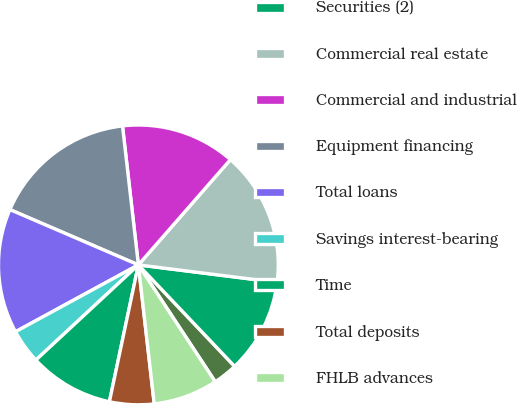<chart> <loc_0><loc_0><loc_500><loc_500><pie_chart><fcel>Short-term investments (1)<fcel>Securities (2)<fcel>Commercial real estate<fcel>Commercial and industrial<fcel>Equipment financing<fcel>Total loans<fcel>Savings interest-bearing<fcel>Time<fcel>Total deposits<fcel>FHLB advances<nl><fcel>2.82%<fcel>10.93%<fcel>15.56%<fcel>13.24%<fcel>16.72%<fcel>14.4%<fcel>3.98%<fcel>9.77%<fcel>5.13%<fcel>7.45%<nl></chart> 